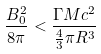Convert formula to latex. <formula><loc_0><loc_0><loc_500><loc_500>\frac { B _ { 0 } ^ { 2 } } { 8 \pi } < \frac { \Gamma M c ^ { 2 } } { \frac { 4 } { 3 } \pi R ^ { 3 } }</formula> 